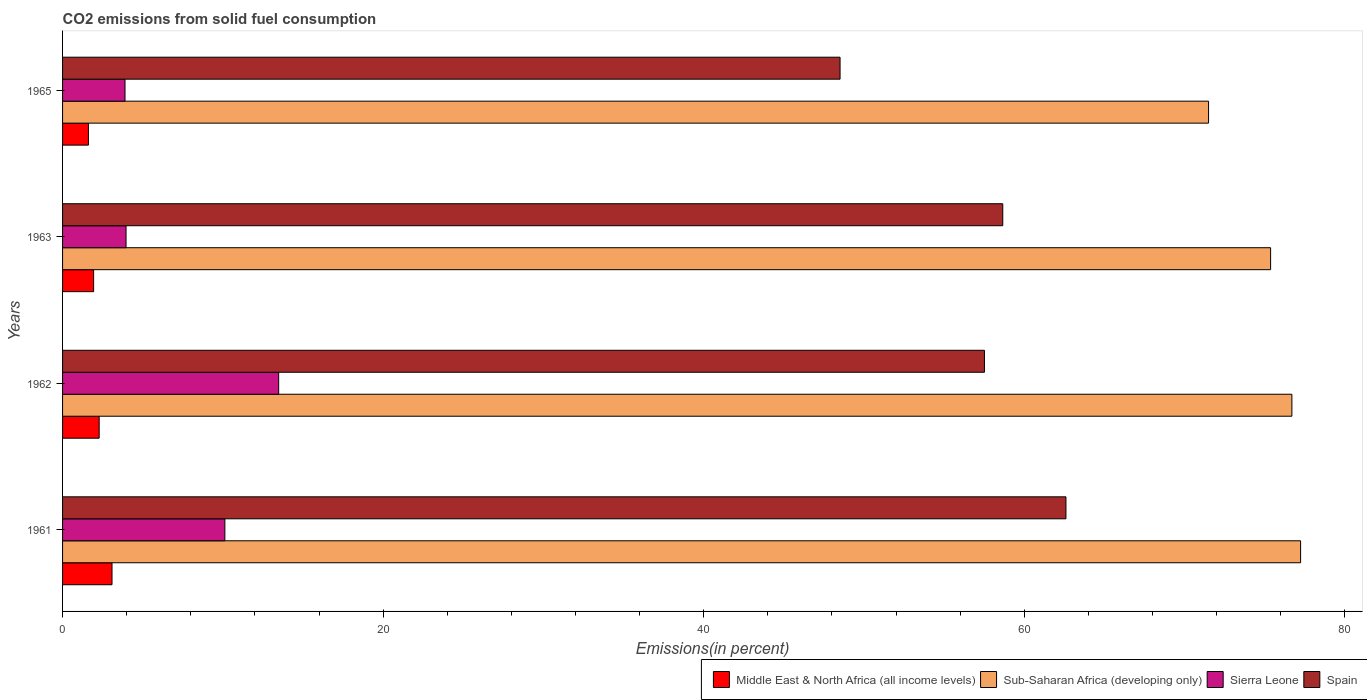Are the number of bars per tick equal to the number of legend labels?
Keep it short and to the point. Yes. How many bars are there on the 1st tick from the top?
Your answer should be compact. 4. How many bars are there on the 2nd tick from the bottom?
Provide a short and direct response. 4. What is the total CO2 emitted in Sierra Leone in 1962?
Make the answer very short. 13.48. Across all years, what is the maximum total CO2 emitted in Middle East & North Africa (all income levels)?
Keep it short and to the point. 3.09. Across all years, what is the minimum total CO2 emitted in Spain?
Give a very brief answer. 48.51. In which year was the total CO2 emitted in Middle East & North Africa (all income levels) minimum?
Your answer should be compact. 1965. What is the total total CO2 emitted in Sierra Leone in the graph?
Ensure brevity in your answer.  31.47. What is the difference between the total CO2 emitted in Sub-Saharan Africa (developing only) in 1962 and that in 1965?
Ensure brevity in your answer.  5.2. What is the difference between the total CO2 emitted in Sierra Leone in 1965 and the total CO2 emitted in Sub-Saharan Africa (developing only) in 1963?
Offer a very short reply. -71.48. What is the average total CO2 emitted in Sierra Leone per year?
Your response must be concise. 7.87. In the year 1962, what is the difference between the total CO2 emitted in Spain and total CO2 emitted in Middle East & North Africa (all income levels)?
Ensure brevity in your answer.  55.24. What is the ratio of the total CO2 emitted in Sierra Leone in 1962 to that in 1963?
Make the answer very short. 3.4. Is the total CO2 emitted in Sierra Leone in 1961 less than that in 1962?
Provide a succinct answer. Yes. Is the difference between the total CO2 emitted in Spain in 1962 and 1965 greater than the difference between the total CO2 emitted in Middle East & North Africa (all income levels) in 1962 and 1965?
Provide a short and direct response. Yes. What is the difference between the highest and the second highest total CO2 emitted in Sub-Saharan Africa (developing only)?
Your answer should be compact. 0.54. What is the difference between the highest and the lowest total CO2 emitted in Sub-Saharan Africa (developing only)?
Give a very brief answer. 5.74. In how many years, is the total CO2 emitted in Spain greater than the average total CO2 emitted in Spain taken over all years?
Your answer should be compact. 3. Is it the case that in every year, the sum of the total CO2 emitted in Sierra Leone and total CO2 emitted in Middle East & North Africa (all income levels) is greater than the sum of total CO2 emitted in Spain and total CO2 emitted in Sub-Saharan Africa (developing only)?
Make the answer very short. Yes. What does the 2nd bar from the top in 1961 represents?
Your answer should be compact. Sierra Leone. What does the 3rd bar from the bottom in 1963 represents?
Make the answer very short. Sierra Leone. Is it the case that in every year, the sum of the total CO2 emitted in Spain and total CO2 emitted in Sub-Saharan Africa (developing only) is greater than the total CO2 emitted in Sierra Leone?
Your response must be concise. Yes. How many bars are there?
Offer a very short reply. 16. Are the values on the major ticks of X-axis written in scientific E-notation?
Offer a very short reply. No. Does the graph contain grids?
Keep it short and to the point. No. What is the title of the graph?
Provide a succinct answer. CO2 emissions from solid fuel consumption. Does "Dominica" appear as one of the legend labels in the graph?
Provide a succinct answer. No. What is the label or title of the X-axis?
Keep it short and to the point. Emissions(in percent). What is the Emissions(in percent) of Middle East & North Africa (all income levels) in 1961?
Provide a succinct answer. 3.09. What is the Emissions(in percent) in Sub-Saharan Africa (developing only) in 1961?
Offer a terse response. 77.24. What is the Emissions(in percent) in Sierra Leone in 1961?
Provide a short and direct response. 10.13. What is the Emissions(in percent) in Spain in 1961?
Make the answer very short. 62.6. What is the Emissions(in percent) in Middle East & North Africa (all income levels) in 1962?
Provide a short and direct response. 2.28. What is the Emissions(in percent) in Sub-Saharan Africa (developing only) in 1962?
Keep it short and to the point. 76.7. What is the Emissions(in percent) of Sierra Leone in 1962?
Your answer should be very brief. 13.48. What is the Emissions(in percent) in Spain in 1962?
Offer a very short reply. 57.52. What is the Emissions(in percent) of Middle East & North Africa (all income levels) in 1963?
Your answer should be very brief. 1.94. What is the Emissions(in percent) of Sub-Saharan Africa (developing only) in 1963?
Offer a very short reply. 75.37. What is the Emissions(in percent) in Sierra Leone in 1963?
Ensure brevity in your answer.  3.96. What is the Emissions(in percent) in Spain in 1963?
Give a very brief answer. 58.66. What is the Emissions(in percent) of Middle East & North Africa (all income levels) in 1965?
Offer a terse response. 1.61. What is the Emissions(in percent) in Sub-Saharan Africa (developing only) in 1965?
Give a very brief answer. 71.5. What is the Emissions(in percent) of Sierra Leone in 1965?
Ensure brevity in your answer.  3.9. What is the Emissions(in percent) of Spain in 1965?
Your response must be concise. 48.51. Across all years, what is the maximum Emissions(in percent) in Middle East & North Africa (all income levels)?
Give a very brief answer. 3.09. Across all years, what is the maximum Emissions(in percent) of Sub-Saharan Africa (developing only)?
Provide a succinct answer. 77.24. Across all years, what is the maximum Emissions(in percent) of Sierra Leone?
Give a very brief answer. 13.48. Across all years, what is the maximum Emissions(in percent) of Spain?
Offer a terse response. 62.6. Across all years, what is the minimum Emissions(in percent) in Middle East & North Africa (all income levels)?
Give a very brief answer. 1.61. Across all years, what is the minimum Emissions(in percent) in Sub-Saharan Africa (developing only)?
Keep it short and to the point. 71.5. Across all years, what is the minimum Emissions(in percent) in Sierra Leone?
Your answer should be compact. 3.9. Across all years, what is the minimum Emissions(in percent) of Spain?
Provide a short and direct response. 48.51. What is the total Emissions(in percent) of Middle East & North Africa (all income levels) in the graph?
Your response must be concise. 8.92. What is the total Emissions(in percent) in Sub-Saharan Africa (developing only) in the graph?
Keep it short and to the point. 300.82. What is the total Emissions(in percent) of Sierra Leone in the graph?
Provide a short and direct response. 31.47. What is the total Emissions(in percent) of Spain in the graph?
Keep it short and to the point. 227.3. What is the difference between the Emissions(in percent) of Middle East & North Africa (all income levels) in 1961 and that in 1962?
Make the answer very short. 0.8. What is the difference between the Emissions(in percent) in Sub-Saharan Africa (developing only) in 1961 and that in 1962?
Give a very brief answer. 0.54. What is the difference between the Emissions(in percent) of Sierra Leone in 1961 and that in 1962?
Offer a very short reply. -3.36. What is the difference between the Emissions(in percent) in Spain in 1961 and that in 1962?
Your answer should be very brief. 5.08. What is the difference between the Emissions(in percent) in Middle East & North Africa (all income levels) in 1961 and that in 1963?
Provide a succinct answer. 1.15. What is the difference between the Emissions(in percent) in Sub-Saharan Africa (developing only) in 1961 and that in 1963?
Give a very brief answer. 1.87. What is the difference between the Emissions(in percent) of Sierra Leone in 1961 and that in 1963?
Ensure brevity in your answer.  6.17. What is the difference between the Emissions(in percent) of Spain in 1961 and that in 1963?
Provide a succinct answer. 3.94. What is the difference between the Emissions(in percent) in Middle East & North Africa (all income levels) in 1961 and that in 1965?
Offer a very short reply. 1.47. What is the difference between the Emissions(in percent) in Sub-Saharan Africa (developing only) in 1961 and that in 1965?
Make the answer very short. 5.74. What is the difference between the Emissions(in percent) in Sierra Leone in 1961 and that in 1965?
Your answer should be very brief. 6.23. What is the difference between the Emissions(in percent) in Spain in 1961 and that in 1965?
Keep it short and to the point. 14.09. What is the difference between the Emissions(in percent) in Middle East & North Africa (all income levels) in 1962 and that in 1963?
Keep it short and to the point. 0.35. What is the difference between the Emissions(in percent) of Sub-Saharan Africa (developing only) in 1962 and that in 1963?
Give a very brief answer. 1.33. What is the difference between the Emissions(in percent) in Sierra Leone in 1962 and that in 1963?
Provide a short and direct response. 9.52. What is the difference between the Emissions(in percent) of Spain in 1962 and that in 1963?
Provide a succinct answer. -1.14. What is the difference between the Emissions(in percent) in Middle East & North Africa (all income levels) in 1962 and that in 1965?
Provide a succinct answer. 0.67. What is the difference between the Emissions(in percent) in Sub-Saharan Africa (developing only) in 1962 and that in 1965?
Offer a very short reply. 5.2. What is the difference between the Emissions(in percent) in Sierra Leone in 1962 and that in 1965?
Your answer should be very brief. 9.59. What is the difference between the Emissions(in percent) in Spain in 1962 and that in 1965?
Offer a very short reply. 9.01. What is the difference between the Emissions(in percent) of Middle East & North Africa (all income levels) in 1963 and that in 1965?
Your response must be concise. 0.32. What is the difference between the Emissions(in percent) of Sub-Saharan Africa (developing only) in 1963 and that in 1965?
Offer a terse response. 3.87. What is the difference between the Emissions(in percent) in Sierra Leone in 1963 and that in 1965?
Make the answer very short. 0.06. What is the difference between the Emissions(in percent) of Spain in 1963 and that in 1965?
Make the answer very short. 10.15. What is the difference between the Emissions(in percent) in Middle East & North Africa (all income levels) in 1961 and the Emissions(in percent) in Sub-Saharan Africa (developing only) in 1962?
Offer a very short reply. -73.62. What is the difference between the Emissions(in percent) of Middle East & North Africa (all income levels) in 1961 and the Emissions(in percent) of Sierra Leone in 1962?
Keep it short and to the point. -10.4. What is the difference between the Emissions(in percent) of Middle East & North Africa (all income levels) in 1961 and the Emissions(in percent) of Spain in 1962?
Ensure brevity in your answer.  -54.43. What is the difference between the Emissions(in percent) of Sub-Saharan Africa (developing only) in 1961 and the Emissions(in percent) of Sierra Leone in 1962?
Your answer should be compact. 63.76. What is the difference between the Emissions(in percent) of Sub-Saharan Africa (developing only) in 1961 and the Emissions(in percent) of Spain in 1962?
Keep it short and to the point. 19.72. What is the difference between the Emissions(in percent) of Sierra Leone in 1961 and the Emissions(in percent) of Spain in 1962?
Keep it short and to the point. -47.39. What is the difference between the Emissions(in percent) in Middle East & North Africa (all income levels) in 1961 and the Emissions(in percent) in Sub-Saharan Africa (developing only) in 1963?
Keep it short and to the point. -72.29. What is the difference between the Emissions(in percent) of Middle East & North Africa (all income levels) in 1961 and the Emissions(in percent) of Sierra Leone in 1963?
Offer a terse response. -0.88. What is the difference between the Emissions(in percent) in Middle East & North Africa (all income levels) in 1961 and the Emissions(in percent) in Spain in 1963?
Offer a terse response. -55.58. What is the difference between the Emissions(in percent) in Sub-Saharan Africa (developing only) in 1961 and the Emissions(in percent) in Sierra Leone in 1963?
Your answer should be very brief. 73.28. What is the difference between the Emissions(in percent) in Sub-Saharan Africa (developing only) in 1961 and the Emissions(in percent) in Spain in 1963?
Provide a short and direct response. 18.58. What is the difference between the Emissions(in percent) in Sierra Leone in 1961 and the Emissions(in percent) in Spain in 1963?
Offer a terse response. -48.54. What is the difference between the Emissions(in percent) of Middle East & North Africa (all income levels) in 1961 and the Emissions(in percent) of Sub-Saharan Africa (developing only) in 1965?
Keep it short and to the point. -68.42. What is the difference between the Emissions(in percent) in Middle East & North Africa (all income levels) in 1961 and the Emissions(in percent) in Sierra Leone in 1965?
Provide a short and direct response. -0.81. What is the difference between the Emissions(in percent) of Middle East & North Africa (all income levels) in 1961 and the Emissions(in percent) of Spain in 1965?
Offer a very short reply. -45.42. What is the difference between the Emissions(in percent) of Sub-Saharan Africa (developing only) in 1961 and the Emissions(in percent) of Sierra Leone in 1965?
Ensure brevity in your answer.  73.35. What is the difference between the Emissions(in percent) of Sub-Saharan Africa (developing only) in 1961 and the Emissions(in percent) of Spain in 1965?
Provide a short and direct response. 28.73. What is the difference between the Emissions(in percent) in Sierra Leone in 1961 and the Emissions(in percent) in Spain in 1965?
Your answer should be compact. -38.38. What is the difference between the Emissions(in percent) in Middle East & North Africa (all income levels) in 1962 and the Emissions(in percent) in Sub-Saharan Africa (developing only) in 1963?
Provide a succinct answer. -73.09. What is the difference between the Emissions(in percent) of Middle East & North Africa (all income levels) in 1962 and the Emissions(in percent) of Sierra Leone in 1963?
Your answer should be very brief. -1.68. What is the difference between the Emissions(in percent) in Middle East & North Africa (all income levels) in 1962 and the Emissions(in percent) in Spain in 1963?
Make the answer very short. -56.38. What is the difference between the Emissions(in percent) of Sub-Saharan Africa (developing only) in 1962 and the Emissions(in percent) of Sierra Leone in 1963?
Your response must be concise. 72.74. What is the difference between the Emissions(in percent) of Sub-Saharan Africa (developing only) in 1962 and the Emissions(in percent) of Spain in 1963?
Your response must be concise. 18.04. What is the difference between the Emissions(in percent) of Sierra Leone in 1962 and the Emissions(in percent) of Spain in 1963?
Provide a succinct answer. -45.18. What is the difference between the Emissions(in percent) of Middle East & North Africa (all income levels) in 1962 and the Emissions(in percent) of Sub-Saharan Africa (developing only) in 1965?
Provide a succinct answer. -69.22. What is the difference between the Emissions(in percent) in Middle East & North Africa (all income levels) in 1962 and the Emissions(in percent) in Sierra Leone in 1965?
Give a very brief answer. -1.61. What is the difference between the Emissions(in percent) in Middle East & North Africa (all income levels) in 1962 and the Emissions(in percent) in Spain in 1965?
Your answer should be compact. -46.23. What is the difference between the Emissions(in percent) in Sub-Saharan Africa (developing only) in 1962 and the Emissions(in percent) in Sierra Leone in 1965?
Your response must be concise. 72.8. What is the difference between the Emissions(in percent) of Sub-Saharan Africa (developing only) in 1962 and the Emissions(in percent) of Spain in 1965?
Give a very brief answer. 28.19. What is the difference between the Emissions(in percent) in Sierra Leone in 1962 and the Emissions(in percent) in Spain in 1965?
Give a very brief answer. -35.03. What is the difference between the Emissions(in percent) in Middle East & North Africa (all income levels) in 1963 and the Emissions(in percent) in Sub-Saharan Africa (developing only) in 1965?
Keep it short and to the point. -69.56. What is the difference between the Emissions(in percent) in Middle East & North Africa (all income levels) in 1963 and the Emissions(in percent) in Sierra Leone in 1965?
Make the answer very short. -1.96. What is the difference between the Emissions(in percent) of Middle East & North Africa (all income levels) in 1963 and the Emissions(in percent) of Spain in 1965?
Make the answer very short. -46.57. What is the difference between the Emissions(in percent) of Sub-Saharan Africa (developing only) in 1963 and the Emissions(in percent) of Sierra Leone in 1965?
Offer a very short reply. 71.48. What is the difference between the Emissions(in percent) of Sub-Saharan Africa (developing only) in 1963 and the Emissions(in percent) of Spain in 1965?
Provide a short and direct response. 26.86. What is the difference between the Emissions(in percent) in Sierra Leone in 1963 and the Emissions(in percent) in Spain in 1965?
Offer a terse response. -44.55. What is the average Emissions(in percent) of Middle East & North Africa (all income levels) per year?
Your response must be concise. 2.23. What is the average Emissions(in percent) in Sub-Saharan Africa (developing only) per year?
Offer a terse response. 75.21. What is the average Emissions(in percent) in Sierra Leone per year?
Offer a terse response. 7.87. What is the average Emissions(in percent) in Spain per year?
Your response must be concise. 56.82. In the year 1961, what is the difference between the Emissions(in percent) in Middle East & North Africa (all income levels) and Emissions(in percent) in Sub-Saharan Africa (developing only)?
Provide a succinct answer. -74.16. In the year 1961, what is the difference between the Emissions(in percent) of Middle East & North Africa (all income levels) and Emissions(in percent) of Sierra Leone?
Provide a short and direct response. -7.04. In the year 1961, what is the difference between the Emissions(in percent) of Middle East & North Africa (all income levels) and Emissions(in percent) of Spain?
Provide a succinct answer. -59.52. In the year 1961, what is the difference between the Emissions(in percent) of Sub-Saharan Africa (developing only) and Emissions(in percent) of Sierra Leone?
Offer a very short reply. 67.12. In the year 1961, what is the difference between the Emissions(in percent) in Sub-Saharan Africa (developing only) and Emissions(in percent) in Spain?
Give a very brief answer. 14.64. In the year 1961, what is the difference between the Emissions(in percent) of Sierra Leone and Emissions(in percent) of Spain?
Provide a short and direct response. -52.48. In the year 1962, what is the difference between the Emissions(in percent) in Middle East & North Africa (all income levels) and Emissions(in percent) in Sub-Saharan Africa (developing only)?
Offer a very short reply. -74.42. In the year 1962, what is the difference between the Emissions(in percent) in Middle East & North Africa (all income levels) and Emissions(in percent) in Sierra Leone?
Provide a short and direct response. -11.2. In the year 1962, what is the difference between the Emissions(in percent) in Middle East & North Africa (all income levels) and Emissions(in percent) in Spain?
Your answer should be compact. -55.24. In the year 1962, what is the difference between the Emissions(in percent) of Sub-Saharan Africa (developing only) and Emissions(in percent) of Sierra Leone?
Provide a short and direct response. 63.22. In the year 1962, what is the difference between the Emissions(in percent) of Sub-Saharan Africa (developing only) and Emissions(in percent) of Spain?
Your answer should be very brief. 19.18. In the year 1962, what is the difference between the Emissions(in percent) in Sierra Leone and Emissions(in percent) in Spain?
Ensure brevity in your answer.  -44.04. In the year 1963, what is the difference between the Emissions(in percent) of Middle East & North Africa (all income levels) and Emissions(in percent) of Sub-Saharan Africa (developing only)?
Your response must be concise. -73.44. In the year 1963, what is the difference between the Emissions(in percent) of Middle East & North Africa (all income levels) and Emissions(in percent) of Sierra Leone?
Provide a short and direct response. -2.02. In the year 1963, what is the difference between the Emissions(in percent) of Middle East & North Africa (all income levels) and Emissions(in percent) of Spain?
Offer a very short reply. -56.72. In the year 1963, what is the difference between the Emissions(in percent) in Sub-Saharan Africa (developing only) and Emissions(in percent) in Sierra Leone?
Provide a succinct answer. 71.41. In the year 1963, what is the difference between the Emissions(in percent) in Sub-Saharan Africa (developing only) and Emissions(in percent) in Spain?
Your response must be concise. 16.71. In the year 1963, what is the difference between the Emissions(in percent) in Sierra Leone and Emissions(in percent) in Spain?
Your response must be concise. -54.7. In the year 1965, what is the difference between the Emissions(in percent) in Middle East & North Africa (all income levels) and Emissions(in percent) in Sub-Saharan Africa (developing only)?
Provide a succinct answer. -69.89. In the year 1965, what is the difference between the Emissions(in percent) in Middle East & North Africa (all income levels) and Emissions(in percent) in Sierra Leone?
Keep it short and to the point. -2.28. In the year 1965, what is the difference between the Emissions(in percent) in Middle East & North Africa (all income levels) and Emissions(in percent) in Spain?
Offer a very short reply. -46.9. In the year 1965, what is the difference between the Emissions(in percent) of Sub-Saharan Africa (developing only) and Emissions(in percent) of Sierra Leone?
Offer a very short reply. 67.61. In the year 1965, what is the difference between the Emissions(in percent) in Sub-Saharan Africa (developing only) and Emissions(in percent) in Spain?
Offer a very short reply. 22.99. In the year 1965, what is the difference between the Emissions(in percent) of Sierra Leone and Emissions(in percent) of Spain?
Keep it short and to the point. -44.61. What is the ratio of the Emissions(in percent) of Middle East & North Africa (all income levels) in 1961 to that in 1962?
Give a very brief answer. 1.35. What is the ratio of the Emissions(in percent) in Sub-Saharan Africa (developing only) in 1961 to that in 1962?
Provide a succinct answer. 1.01. What is the ratio of the Emissions(in percent) in Sierra Leone in 1961 to that in 1962?
Give a very brief answer. 0.75. What is the ratio of the Emissions(in percent) in Spain in 1961 to that in 1962?
Give a very brief answer. 1.09. What is the ratio of the Emissions(in percent) of Middle East & North Africa (all income levels) in 1961 to that in 1963?
Provide a short and direct response. 1.59. What is the ratio of the Emissions(in percent) in Sub-Saharan Africa (developing only) in 1961 to that in 1963?
Your answer should be compact. 1.02. What is the ratio of the Emissions(in percent) in Sierra Leone in 1961 to that in 1963?
Provide a succinct answer. 2.56. What is the ratio of the Emissions(in percent) in Spain in 1961 to that in 1963?
Your answer should be compact. 1.07. What is the ratio of the Emissions(in percent) of Middle East & North Africa (all income levels) in 1961 to that in 1965?
Offer a terse response. 1.91. What is the ratio of the Emissions(in percent) of Sub-Saharan Africa (developing only) in 1961 to that in 1965?
Your answer should be compact. 1.08. What is the ratio of the Emissions(in percent) in Sierra Leone in 1961 to that in 1965?
Make the answer very short. 2.6. What is the ratio of the Emissions(in percent) in Spain in 1961 to that in 1965?
Offer a terse response. 1.29. What is the ratio of the Emissions(in percent) in Middle East & North Africa (all income levels) in 1962 to that in 1963?
Keep it short and to the point. 1.18. What is the ratio of the Emissions(in percent) in Sub-Saharan Africa (developing only) in 1962 to that in 1963?
Your answer should be very brief. 1.02. What is the ratio of the Emissions(in percent) of Sierra Leone in 1962 to that in 1963?
Keep it short and to the point. 3.4. What is the ratio of the Emissions(in percent) in Spain in 1962 to that in 1963?
Your answer should be compact. 0.98. What is the ratio of the Emissions(in percent) of Middle East & North Africa (all income levels) in 1962 to that in 1965?
Your answer should be compact. 1.42. What is the ratio of the Emissions(in percent) in Sub-Saharan Africa (developing only) in 1962 to that in 1965?
Make the answer very short. 1.07. What is the ratio of the Emissions(in percent) of Sierra Leone in 1962 to that in 1965?
Give a very brief answer. 3.46. What is the ratio of the Emissions(in percent) in Spain in 1962 to that in 1965?
Provide a short and direct response. 1.19. What is the ratio of the Emissions(in percent) of Middle East & North Africa (all income levels) in 1963 to that in 1965?
Offer a terse response. 1.2. What is the ratio of the Emissions(in percent) in Sub-Saharan Africa (developing only) in 1963 to that in 1965?
Offer a very short reply. 1.05. What is the ratio of the Emissions(in percent) of Sierra Leone in 1963 to that in 1965?
Your response must be concise. 1.02. What is the ratio of the Emissions(in percent) in Spain in 1963 to that in 1965?
Your response must be concise. 1.21. What is the difference between the highest and the second highest Emissions(in percent) of Middle East & North Africa (all income levels)?
Ensure brevity in your answer.  0.8. What is the difference between the highest and the second highest Emissions(in percent) of Sub-Saharan Africa (developing only)?
Ensure brevity in your answer.  0.54. What is the difference between the highest and the second highest Emissions(in percent) of Sierra Leone?
Make the answer very short. 3.36. What is the difference between the highest and the second highest Emissions(in percent) of Spain?
Provide a short and direct response. 3.94. What is the difference between the highest and the lowest Emissions(in percent) of Middle East & North Africa (all income levels)?
Make the answer very short. 1.47. What is the difference between the highest and the lowest Emissions(in percent) of Sub-Saharan Africa (developing only)?
Your answer should be compact. 5.74. What is the difference between the highest and the lowest Emissions(in percent) in Sierra Leone?
Give a very brief answer. 9.59. What is the difference between the highest and the lowest Emissions(in percent) in Spain?
Provide a short and direct response. 14.09. 